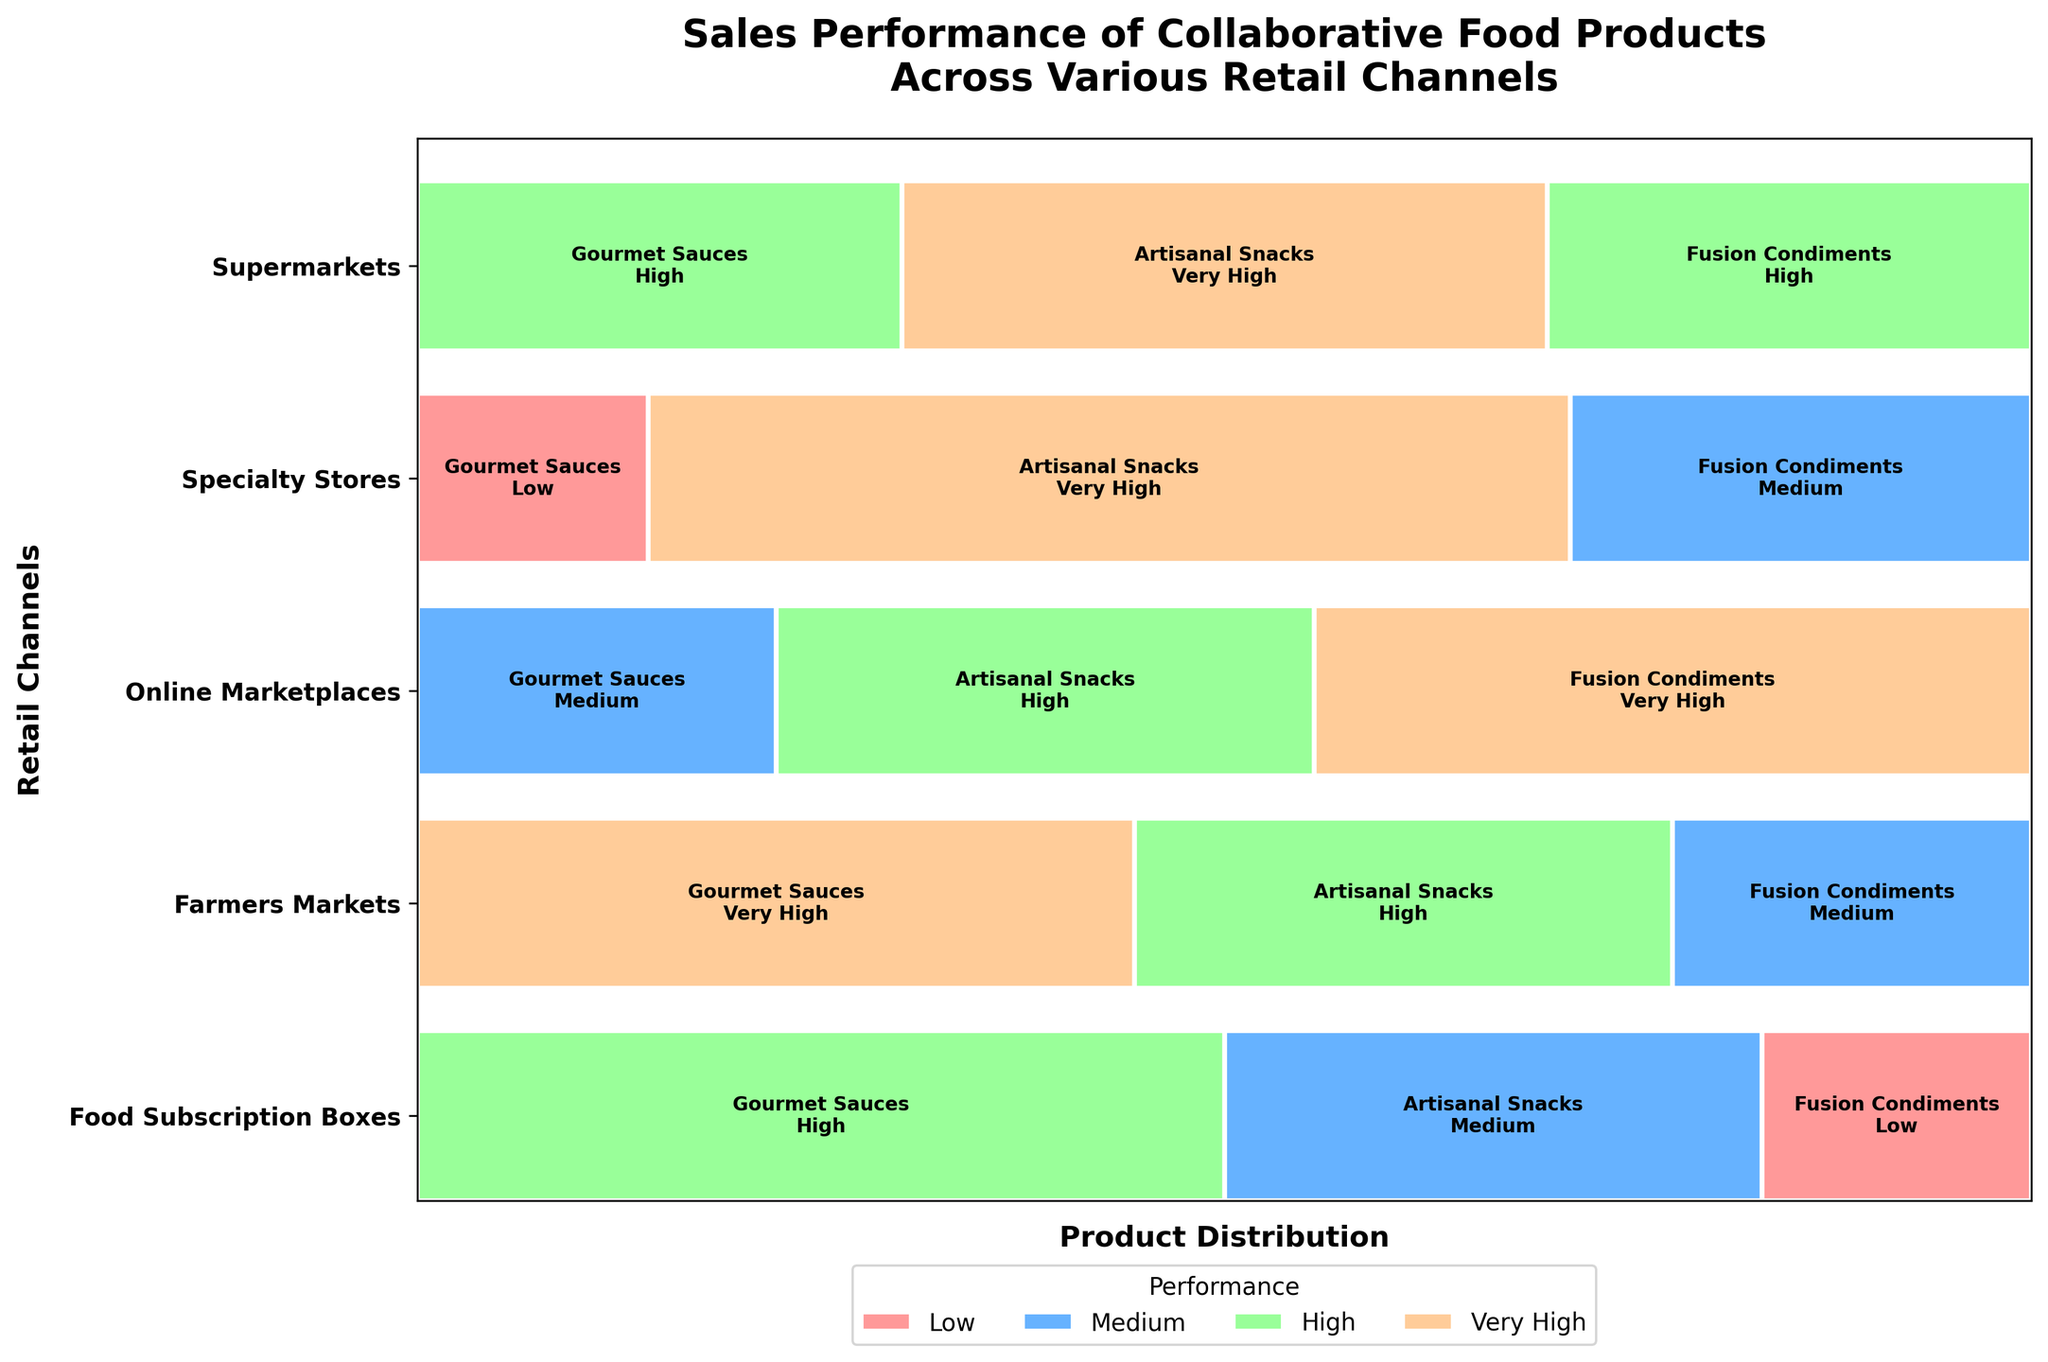What is the title of the figure? The title is typically located at the top of the figure; it summarizes what the entire figure is about. In this case, the title is "Sales Performance of Collaborative Food Products Across Various Retail Channels."
Answer: Sales Performance of Collaborative Food Products Across Various Retail Channels Which retail channel has the highest sales performance for Artisanal Snacks? By examining the different rectangles labeled with retail channels and the sales performance for Artisanal Snacks, identify the one that is marked "Very High." This label is found in the rectangles for both Farmers Markets and Food Subscription Boxes.
Answer: Farmers Markets and Food Subscription Boxes What is the sales performance of Fusion Condiments in Online Marketplaces? Locate the rectangles corresponding to Online Marketplaces, then find the label for Fusion Condiments. The sales performance is indicated within the rectangle. The figure shows "Very High."
Answer: Very High How many different sales performance levels are shown on the figure? The figure uses different colors to indicate sales performance levels. By checking the legend, we can see it displays four performance levels: Low, Medium, High, and Very High.
Answer: Four Which retail channel has the most diversity in sales performance across all product types? Analyze the figure to identify the retail channel that has the most varied colors (representing different performance levels) across the product types. Specialty Stores have Very High, High, and Medium performance, showcasing the greatest diversity.
Answer: Specialty Stores Compare the sales performance of Gourmet Sauces between Specialty Stores and Farmers Markets. Locate the rectangles for Gourmet Sauces under both Specialty Stores and Farmers Markets. The labels within these rectangles indicate the performance levels. Specialty Stores have "Very High" while Farmers Markets have "Low."
Answer: Specialty Stores: Very High, Farmers Markets: Low Which product type has the lowest performance in Supermarkets? Find the sales performance labels within the Supermarkets section. By identifying the lowest performance (marked as "Low"), we see that Fusion Condiments have the lowest performance.
Answer: Fusion Condiments What is the average sales performance score for Artisanal Snacks across all retail channels? Convert the sales performance levels to numerical values (Low: 1, Medium: 2, High: 3, Very High: 4). Artisanal Snacks have Medium (2) in Supermarkets, High (3) in Specialty Stores, High (3) in Online Marketplaces, and Very High (4) in Farmers Markets and Food Subscription Boxes. Calculate the average: (2 + 3 + 3 + 4 + 4) / 5 = 3.2.
Answer: 3.2 How does the performance of Food Subscription Boxes for Fusion Condiments compare with that for Specialty Stores? Identify the sales performance for Fusion Condiments in both retail channels. Food Subscription Boxes have "High," while Specialty Stores have "Medium." Compare these levels.
Answer: Higher in Food Subscription Boxes Considering Supermarkets and Online Marketplaces, which has a higher combined performance score for all product types? First, sum the performance scores for Supermarkets: Gourmet Sauces (3) + Artisanal Snacks (2) + Fusion Condiments (1) = 6. For Online Marketplaces: Gourmet Sauces (2) + Artisanal Snacks (3) + Fusion Condiments (4) = 9. Compare the totals.
Answer: Online Marketplaces: 9, Supermarkets: 6 